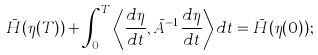Convert formula to latex. <formula><loc_0><loc_0><loc_500><loc_500>\bar { H } ( \eta ( T ) ) + \int _ { 0 } ^ { T } { \left \langle \frac { d \eta } { d t } , \bar { A } ^ { - 1 } \frac { d \eta } { d t } \right \rangle d t } = \bar { H } ( \eta ( 0 ) ) ;</formula> 